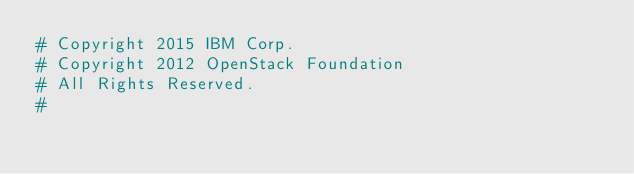<code> <loc_0><loc_0><loc_500><loc_500><_Python_># Copyright 2015 IBM Corp.
# Copyright 2012 OpenStack Foundation
# All Rights Reserved.
#</code> 